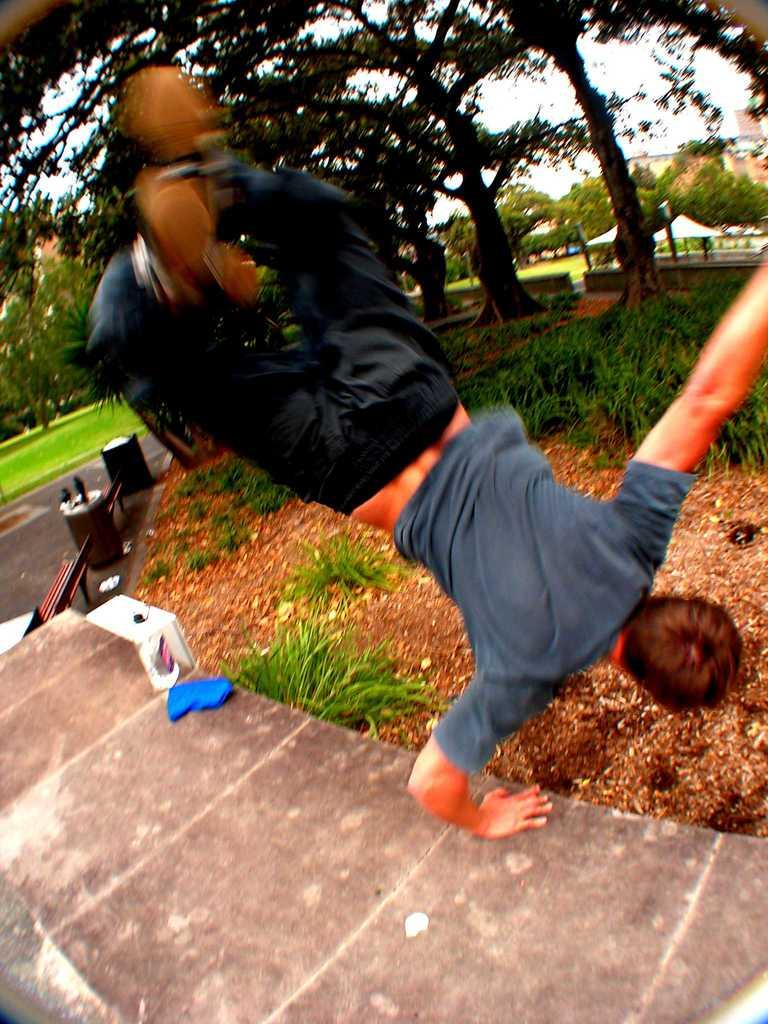What is the main subject of the image? There is a man in the middle of the image. What is the man doing in the image? The man is doing something, but we cannot determine the specific action from the provided facts. What type of natural environment is visible in the background of the image? There is grass, trees, and tents in the background of the image. What type of man-made structures are visible in the background of the image? There are buildings in the background of the image. What type of rock is the man using to brush his teeth in the image? There is no rock or toothbrushing activity present in the image. 